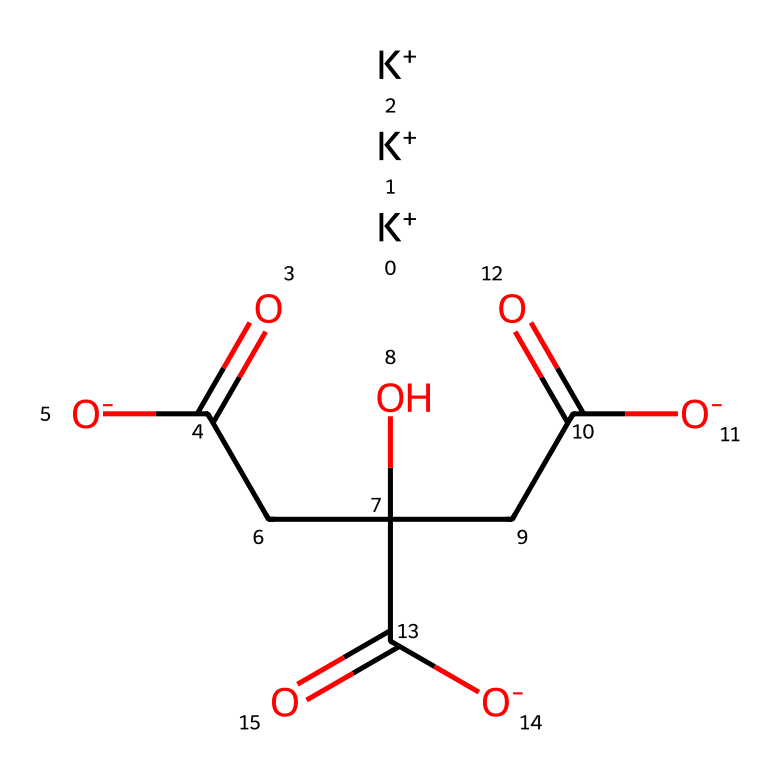What is the name of this compound? The SMILES representation indicates this compound contains potassium (K) and citrate groups, specifically showing potassium citrate as the arrangement, which is commonly found in electrolyte drinks.
Answer: potassium citrate How many potassium ions are present in the molecule? By analyzing the SMILES representation, there are three potassium (K) ions indicated at the beginning, represented by the three instances of [K+].
Answer: three What is the primary functional group in potassium citrate? The SMILES representation shows multiple carboxylate ions (-COO-), indicating that the primary functional groups are carboxylic acids in their deprotonated form as carboxylates.
Answer: carboxylate Which part of the chemical structure acts as a source of potassium? The potassium ions ([K+]) at the beginning of the SMILES representation directly indicate that these ions are the source of potassium in the electrolyte drink.
Answer: potassium ions How many total oxygen atoms are in the molecule? By counting the oxygen atoms in the SMILES representation, we find there are six oxygen atoms (O), derived from the carboxylate groups and the central structure.
Answer: six What type of electrolyte is potassium citrate considered? Potassium citrate is classified as a mineral electrolyte since it provides potassium and contributes to electrolyte balance in the body.
Answer: mineral electrolyte 